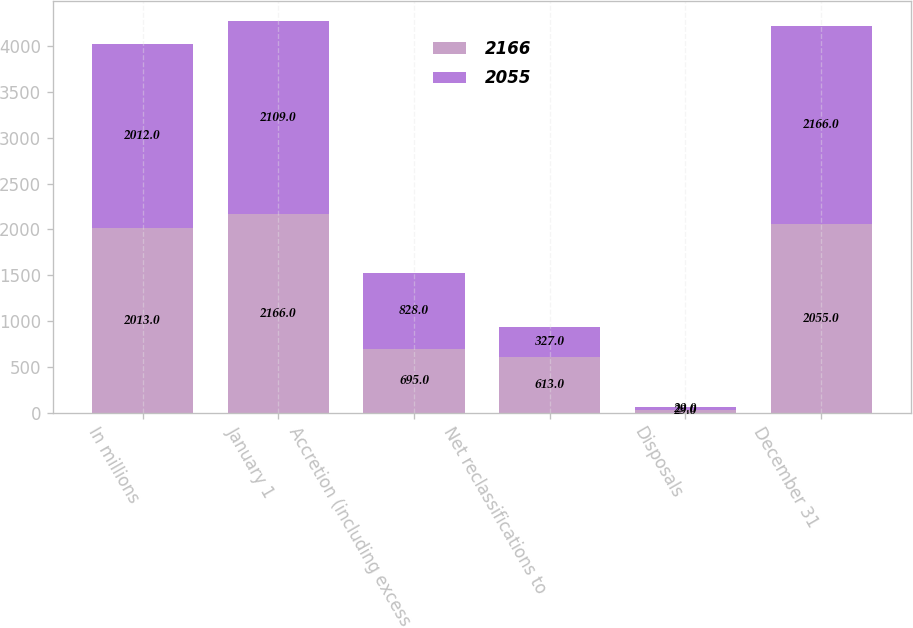Convert chart. <chart><loc_0><loc_0><loc_500><loc_500><stacked_bar_chart><ecel><fcel>In millions<fcel>January 1<fcel>Accretion (including excess<fcel>Net reclassifications to<fcel>Disposals<fcel>December 31<nl><fcel>2166<fcel>2013<fcel>2166<fcel>695<fcel>613<fcel>29<fcel>2055<nl><fcel>2055<fcel>2012<fcel>2109<fcel>828<fcel>327<fcel>29<fcel>2166<nl></chart> 